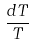Convert formula to latex. <formula><loc_0><loc_0><loc_500><loc_500>\frac { d T } { T }</formula> 